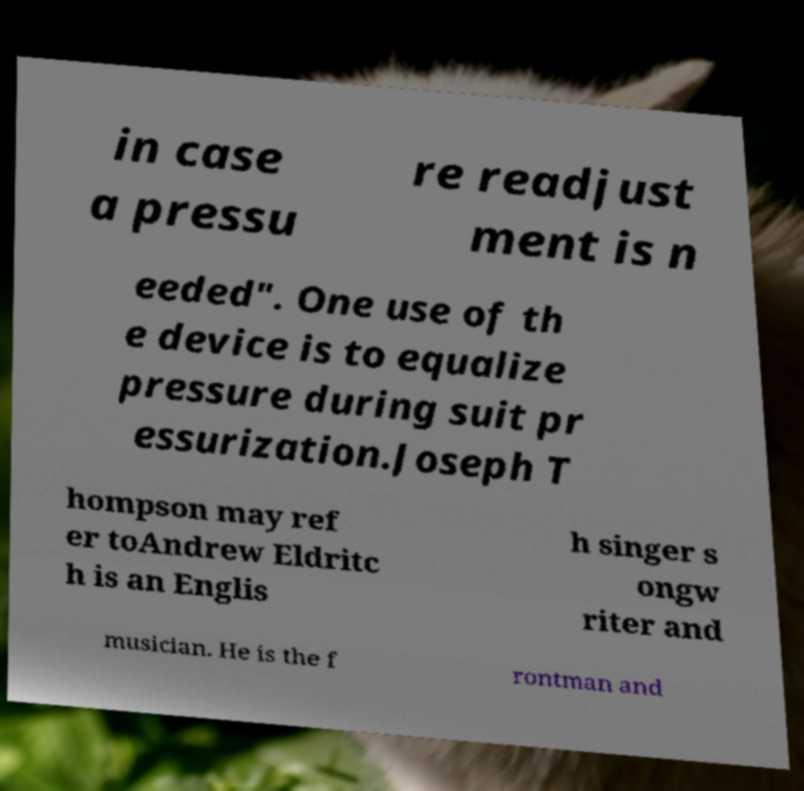Can you read and provide the text displayed in the image?This photo seems to have some interesting text. Can you extract and type it out for me? in case a pressu re readjust ment is n eeded". One use of th e device is to equalize pressure during suit pr essurization.Joseph T hompson may ref er toAndrew Eldritc h is an Englis h singer s ongw riter and musician. He is the f rontman and 